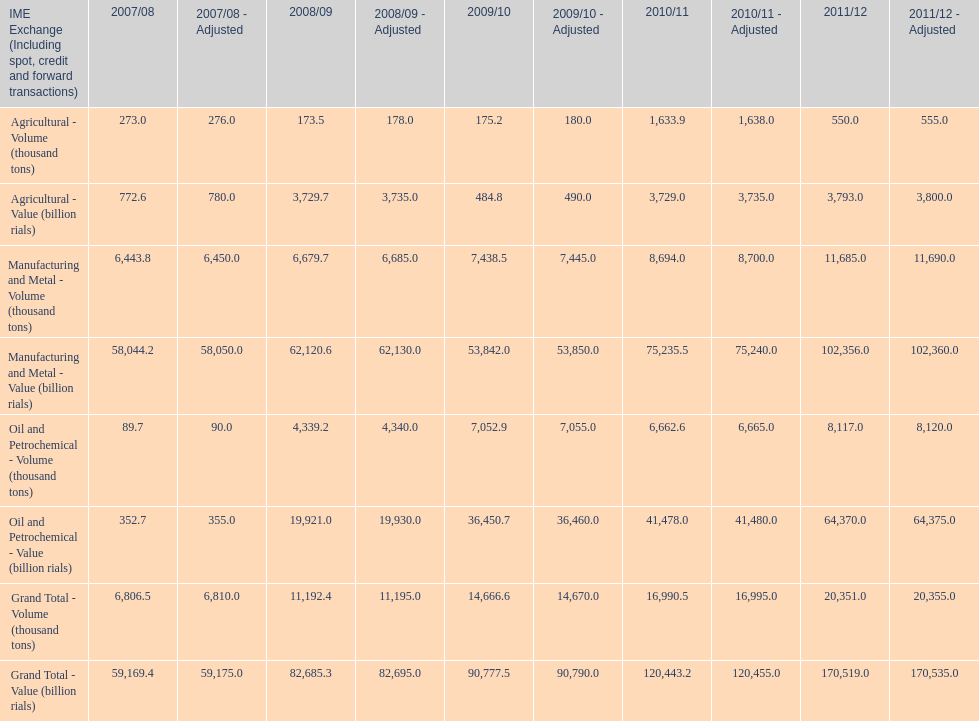Which year had the largest agricultural volume? 2010/11. 